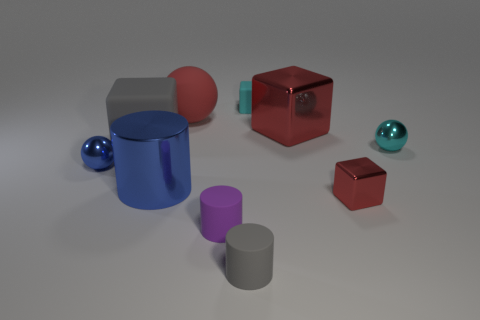What number of other things are the same color as the large rubber sphere?
Offer a very short reply. 2. Do the red block that is behind the cyan shiny ball and the blue metal sphere have the same size?
Provide a succinct answer. No. Is there a gray rubber thing that has the same size as the cyan sphere?
Offer a very short reply. Yes. What color is the metallic sphere that is to the left of the tiny cyan matte cube?
Offer a terse response. Blue. There is a thing that is both in front of the blue cylinder and on the right side of the big metal block; what shape is it?
Keep it short and to the point. Cube. What number of red matte objects are the same shape as the big red metal object?
Your answer should be compact. 0. What number of red metal blocks are there?
Ensure brevity in your answer.  2. There is a rubber thing that is on the right side of the big red rubber sphere and behind the cyan metal object; what is its size?
Your answer should be very brief. Small. What shape is the rubber thing that is the same size as the gray block?
Your answer should be very brief. Sphere. Are there any small purple matte things that are behind the small thing left of the tiny purple rubber object?
Your response must be concise. No. 